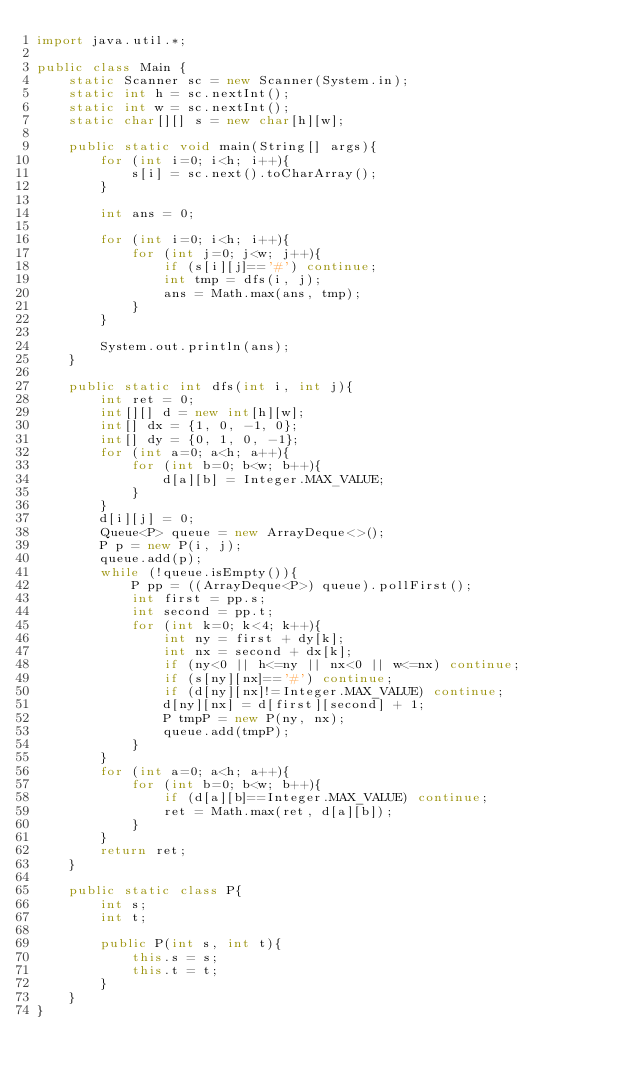<code> <loc_0><loc_0><loc_500><loc_500><_Java_>import java.util.*;

public class Main {
    static Scanner sc = new Scanner(System.in);
    static int h = sc.nextInt();
    static int w = sc.nextInt();
    static char[][] s = new char[h][w];

    public static void main(String[] args){
        for (int i=0; i<h; i++){
            s[i] = sc.next().toCharArray();
        }

        int ans = 0;

        for (int i=0; i<h; i++){
            for (int j=0; j<w; j++){
                if (s[i][j]=='#') continue;
                int tmp = dfs(i, j);
                ans = Math.max(ans, tmp);
            }
        }

        System.out.println(ans);
    }

    public static int dfs(int i, int j){
        int ret = 0;
        int[][] d = new int[h][w];
        int[] dx = {1, 0, -1, 0};
        int[] dy = {0, 1, 0, -1};
        for (int a=0; a<h; a++){
            for (int b=0; b<w; b++){
                d[a][b] = Integer.MAX_VALUE;
            }
        }
        d[i][j] = 0;
        Queue<P> queue = new ArrayDeque<>();
        P p = new P(i, j);
        queue.add(p);
        while (!queue.isEmpty()){
            P pp = ((ArrayDeque<P>) queue).pollFirst();
            int first = pp.s;
            int second = pp.t;
            for (int k=0; k<4; k++){
                int ny = first + dy[k];
                int nx = second + dx[k];
                if (ny<0 || h<=ny || nx<0 || w<=nx) continue;
                if (s[ny][nx]=='#') continue;
                if (d[ny][nx]!=Integer.MAX_VALUE) continue;
                d[ny][nx] = d[first][second] + 1;
                P tmpP = new P(ny, nx);
                queue.add(tmpP);
            }
        }
        for (int a=0; a<h; a++){
            for (int b=0; b<w; b++){
                if (d[a][b]==Integer.MAX_VALUE) continue;
                ret = Math.max(ret, d[a][b]);
            }
        }
        return ret;
    }

    public static class P{
        int s;
        int t;

        public P(int s, int t){
            this.s = s;
            this.t = t;
        }
    }
}
</code> 